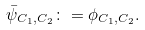Convert formula to latex. <formula><loc_0><loc_0><loc_500><loc_500>\bar { \psi } _ { C _ { 1 } , C _ { 2 } } \colon = \phi _ { C _ { 1 } , C _ { 2 } } .</formula> 